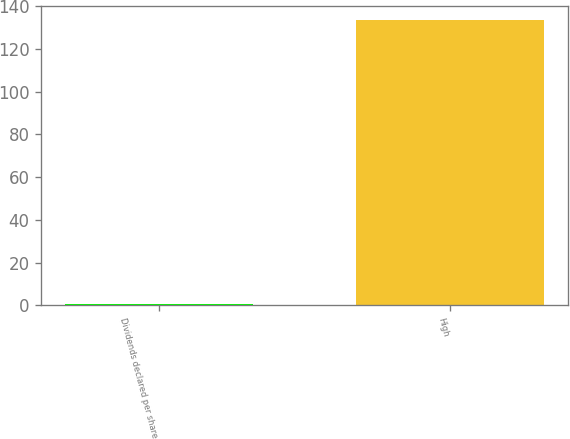Convert chart to OTSL. <chart><loc_0><loc_0><loc_500><loc_500><bar_chart><fcel>Dividends declared per share<fcel>High<nl><fcel>0.42<fcel>133.59<nl></chart> 